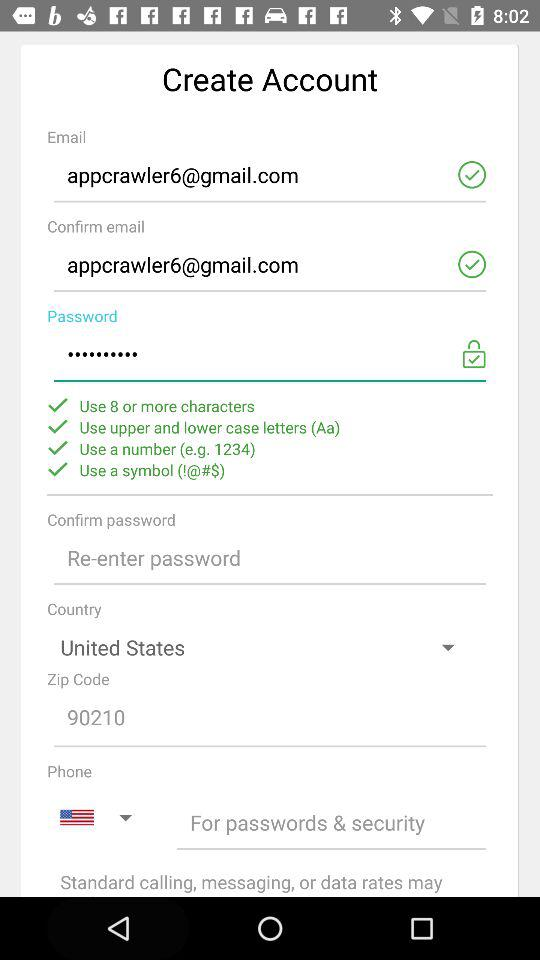How many characters are used for the password? For the password, you can use 8 or more characters. 